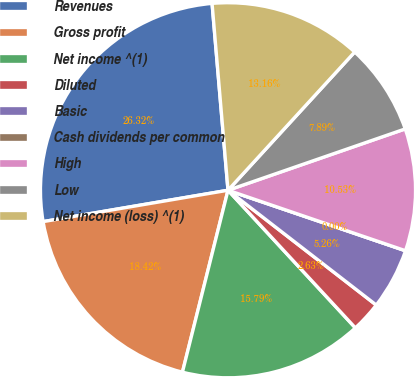Convert chart. <chart><loc_0><loc_0><loc_500><loc_500><pie_chart><fcel>Revenues<fcel>Gross profit<fcel>Net income ^(1)<fcel>Diluted<fcel>Basic<fcel>Cash dividends per common<fcel>High<fcel>Low<fcel>Net income (loss) ^(1)<nl><fcel>26.32%<fcel>18.42%<fcel>15.79%<fcel>2.63%<fcel>5.26%<fcel>0.0%<fcel>10.53%<fcel>7.89%<fcel>13.16%<nl></chart> 